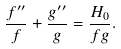Convert formula to latex. <formula><loc_0><loc_0><loc_500><loc_500>\frac { f ^ { \prime \prime } } { f } + \frac { g ^ { \prime \prime } } { g } = \frac { H _ { 0 } } { f g } .</formula> 